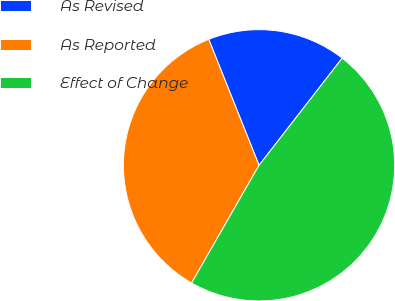Convert chart to OTSL. <chart><loc_0><loc_0><loc_500><loc_500><pie_chart><fcel>As Revised<fcel>As Reported<fcel>Effect of Change<nl><fcel>16.55%<fcel>35.67%<fcel>47.78%<nl></chart> 